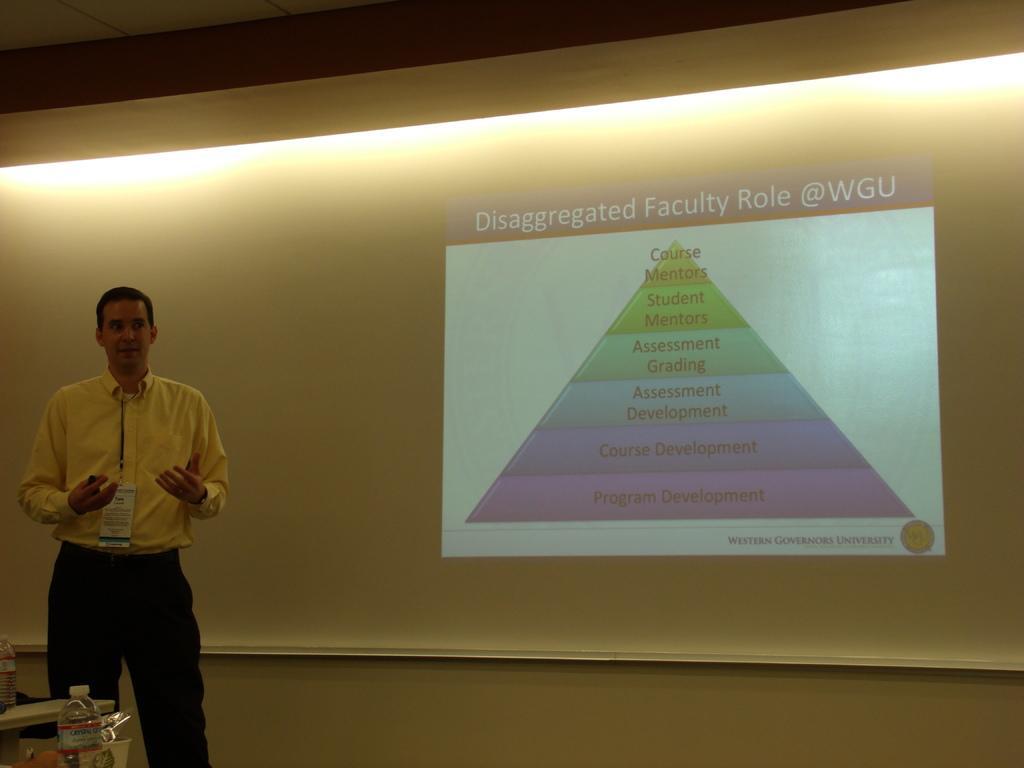Describe this image in one or two sentences. In this image i can see a person standing. In the background i can see a projection screen with some projection in it. 